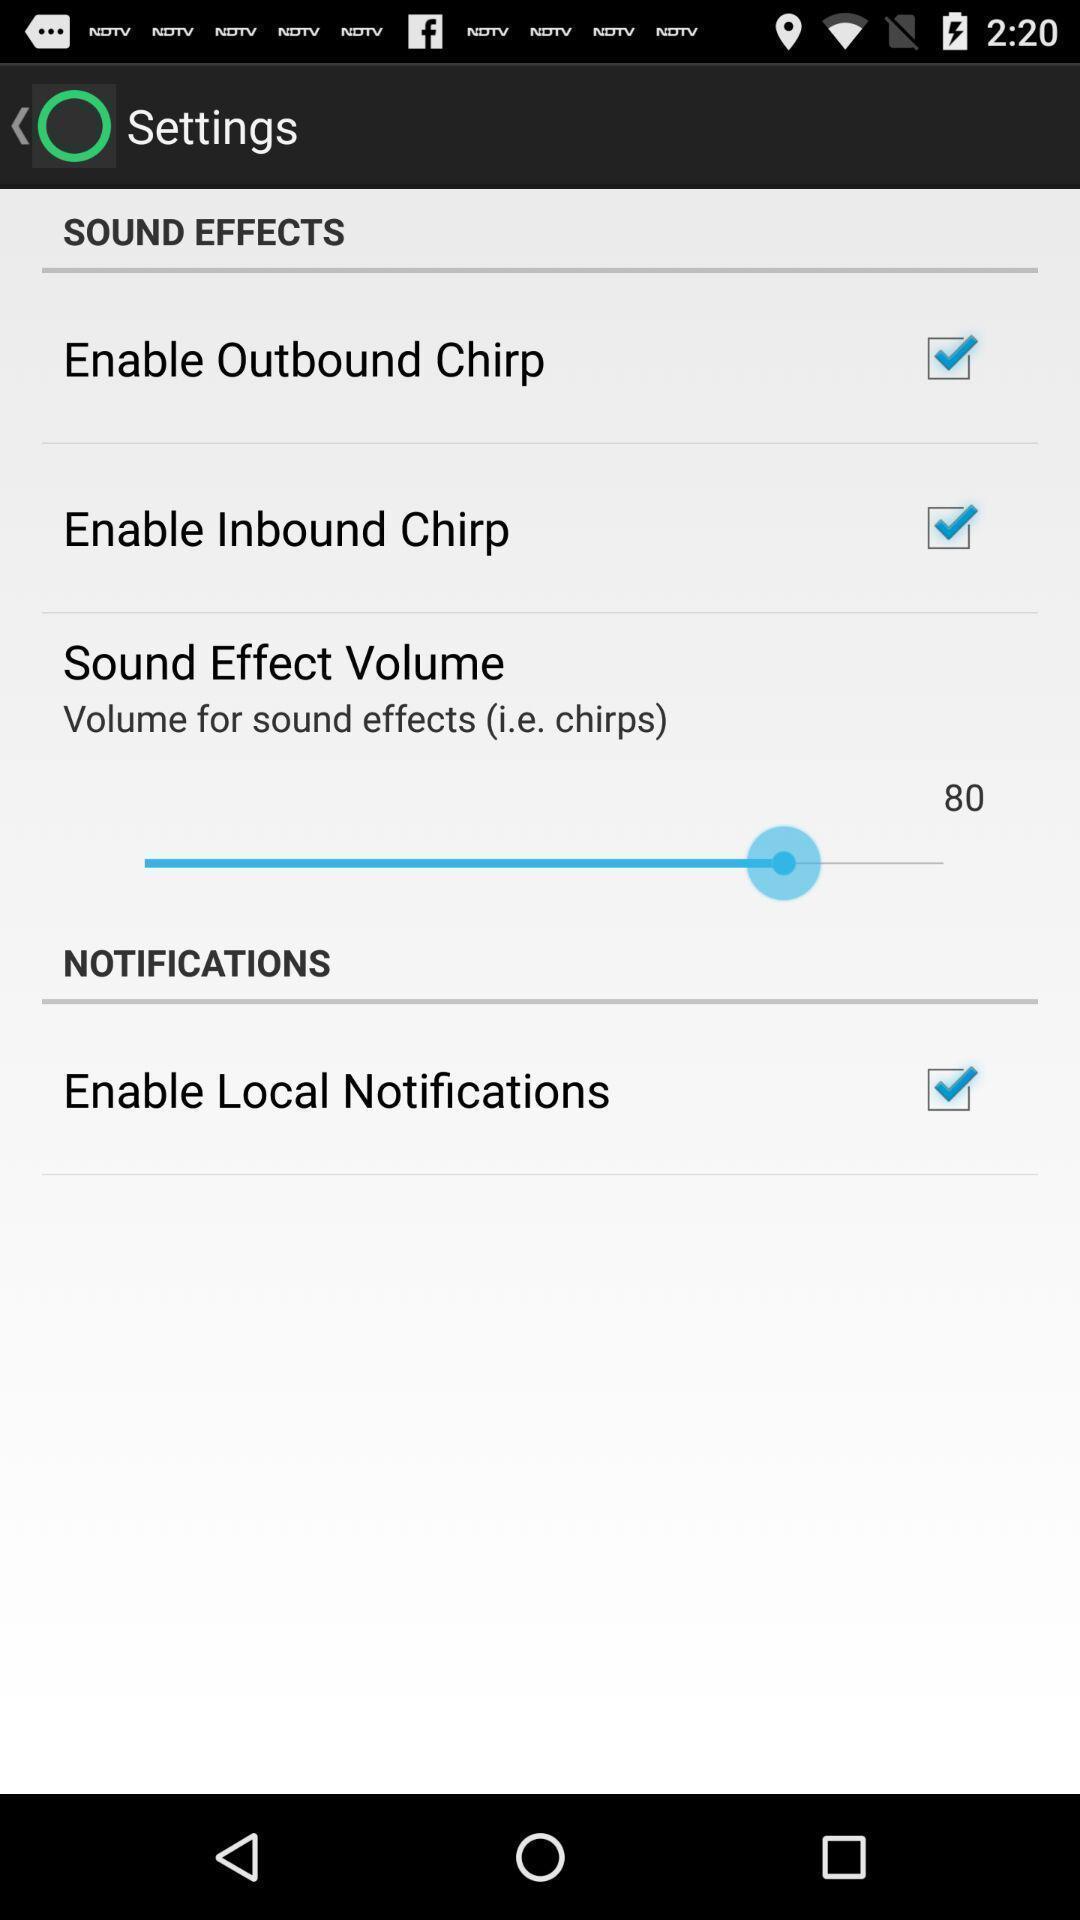Provide a textual representation of this image. Settings page for the sound effects app. 